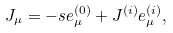Convert formula to latex. <formula><loc_0><loc_0><loc_500><loc_500>J _ { \mu } = - s e ^ { ( 0 ) } _ { \mu } + J ^ { ( i ) } e ^ { ( i ) } _ { \mu } ,</formula> 